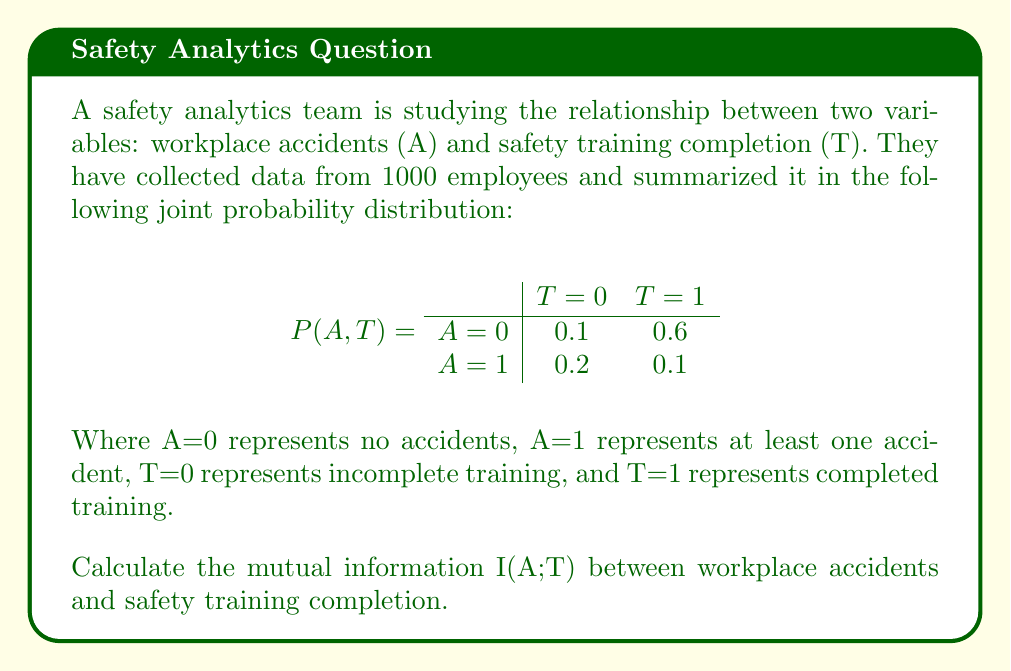Teach me how to tackle this problem. To calculate the mutual information I(A;T), we'll follow these steps:

1. Calculate marginal probabilities P(A) and P(T)
2. Calculate the entropy of A, H(A)
3. Calculate the conditional entropy of A given T, H(A|T)
4. Calculate I(A;T) = H(A) - H(A|T)

Step 1: Marginal probabilities

P(A=0) = 0.1 + 0.6 = 0.7
P(A=1) = 0.2 + 0.1 = 0.3
P(T=0) = 0.1 + 0.2 = 0.3
P(T=1) = 0.6 + 0.1 = 0.7

Step 2: Entropy of A

$$H(A) = -\sum_{a} P(A=a) \log_2 P(A=a)$$
$$H(A) = -[0.7 \log_2(0.7) + 0.3 \log_2(0.3)]$$
$$H(A) \approx 0.8813 \text{ bits}$$

Step 3: Conditional entropy of A given T

$$H(A|T) = -\sum_{t} P(T=t) \sum_{a} P(A=a|T=t) \log_2 P(A=a|T=t)$$

For T=0:
P(A=0|T=0) = 0.1 / 0.3 ≈ 0.3333
P(A=1|T=0) = 0.2 / 0.3 ≈ 0.6667

For T=1:
P(A=0|T=1) = 0.6 / 0.7 ≈ 0.8571
P(A=1|T=1) = 0.1 / 0.7 ≈ 0.1429

$$H(A|T) = -[0.3 * (0.3333 \log_2(0.3333) + 0.6667 \log_2(0.6667)) + $$
$$0.7 * (0.8571 \log_2(0.8571) + 0.1429 \log_2(0.1429))]$$
$$H(A|T) \approx 0.6098 \text{ bits}$$

Step 4: Mutual Information

$$I(A;T) = H(A) - H(A|T)$$
$$I(A;T) = 0.8813 - 0.6098$$
$$I(A;T) \approx 0.2715 \text{ bits}$$
Answer: The mutual information I(A;T) between workplace accidents and safety training completion is approximately 0.2715 bits. 